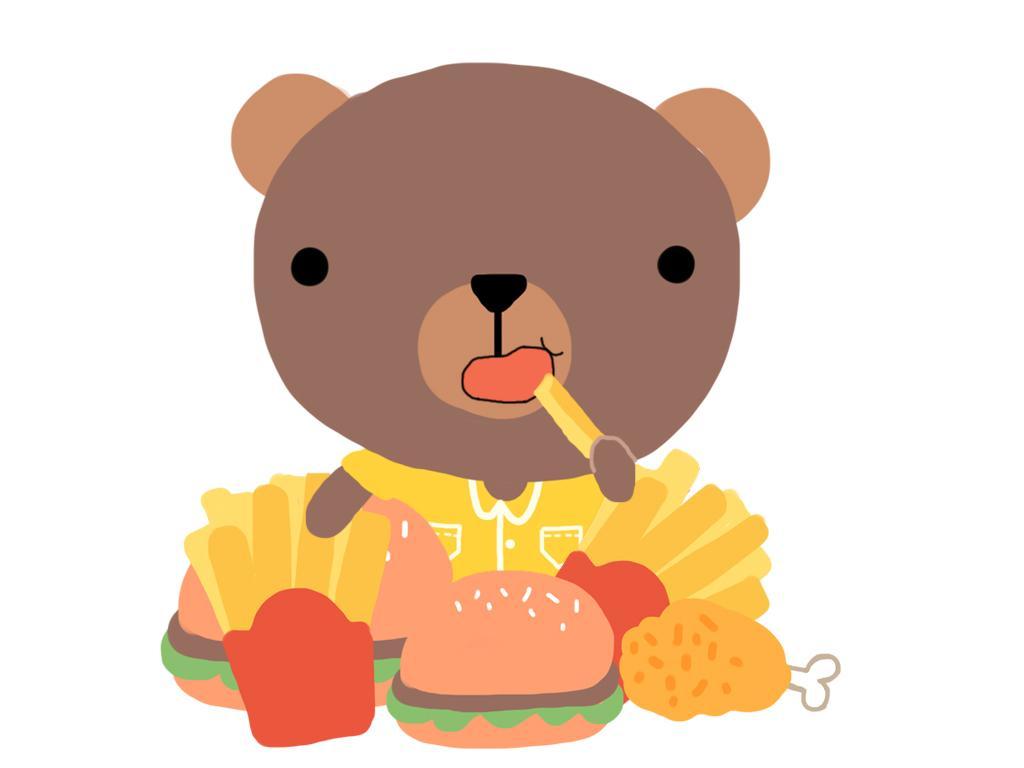Could you give a brief overview of what you see in this image? In this image I can see the digital art of a bear which is wearing yellow colored dress. I can see few french fries, few burgers and a chicken piece in front of it. I can see the white colored background. 